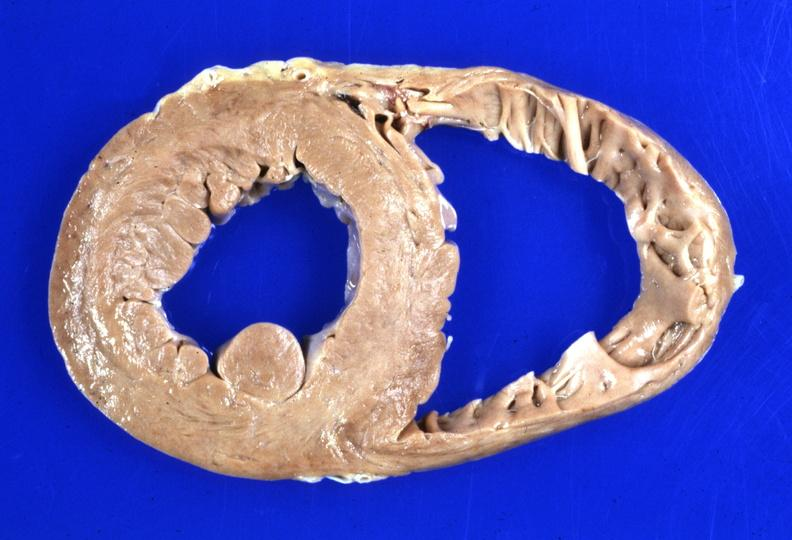what is present?
Answer the question using a single word or phrase. Cardiovascular 